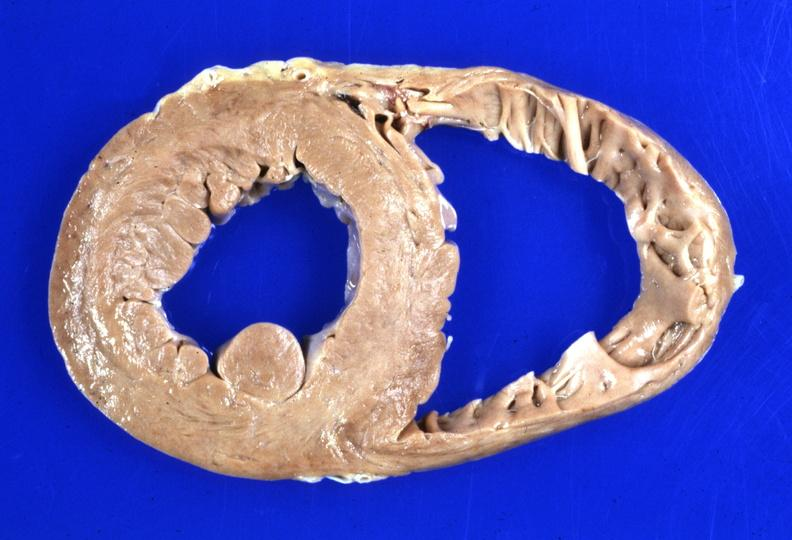what is present?
Answer the question using a single word or phrase. Cardiovascular 